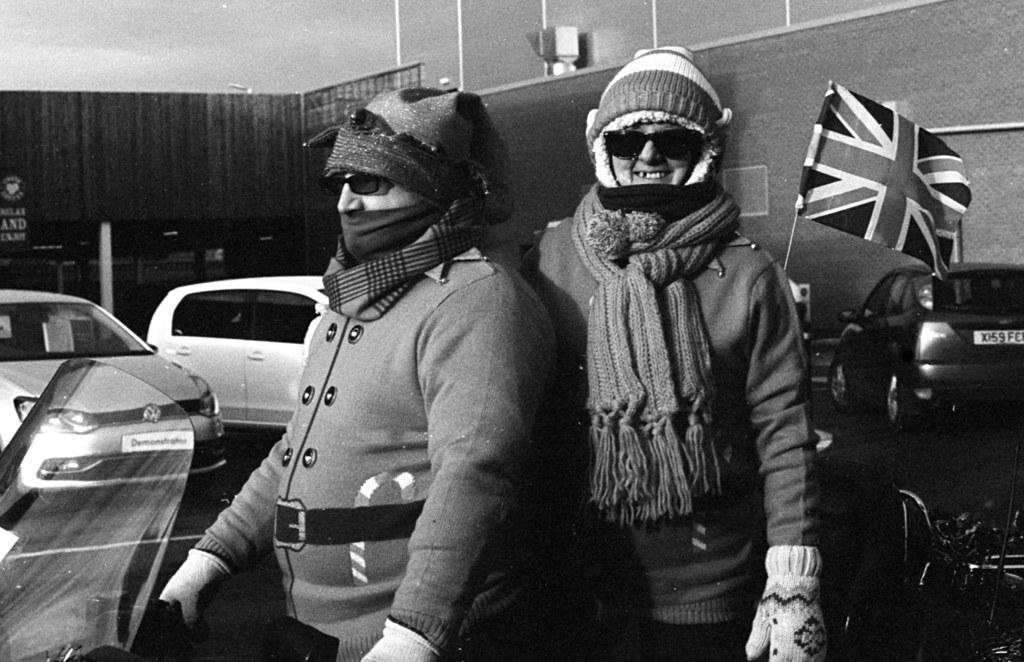How many people are in the image? There are two persons in the image. What else can be seen in the image besides the people? Vehicles, a flag, and a wall are visible in the image. What is visible at the top of the image? The sky is visible at the top of the image. Where is the lamp located in the image? There is no lamp present in the image. What type of group is depicted in the image? There is no group depicted in the image; it features two individuals. 